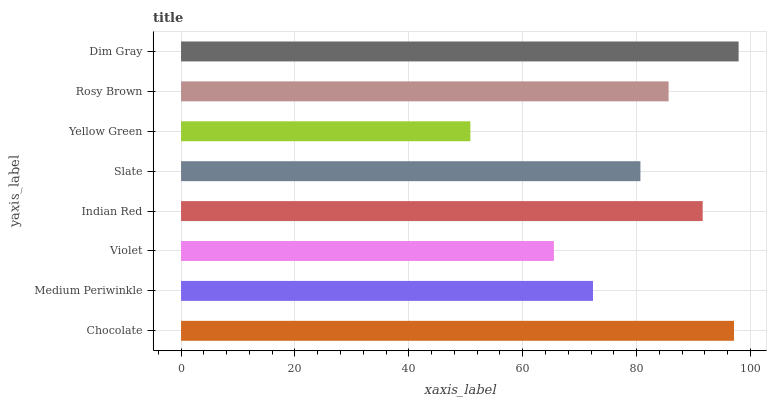Is Yellow Green the minimum?
Answer yes or no. Yes. Is Dim Gray the maximum?
Answer yes or no. Yes. Is Medium Periwinkle the minimum?
Answer yes or no. No. Is Medium Periwinkle the maximum?
Answer yes or no. No. Is Chocolate greater than Medium Periwinkle?
Answer yes or no. Yes. Is Medium Periwinkle less than Chocolate?
Answer yes or no. Yes. Is Medium Periwinkle greater than Chocolate?
Answer yes or no. No. Is Chocolate less than Medium Periwinkle?
Answer yes or no. No. Is Rosy Brown the high median?
Answer yes or no. Yes. Is Slate the low median?
Answer yes or no. Yes. Is Chocolate the high median?
Answer yes or no. No. Is Yellow Green the low median?
Answer yes or no. No. 